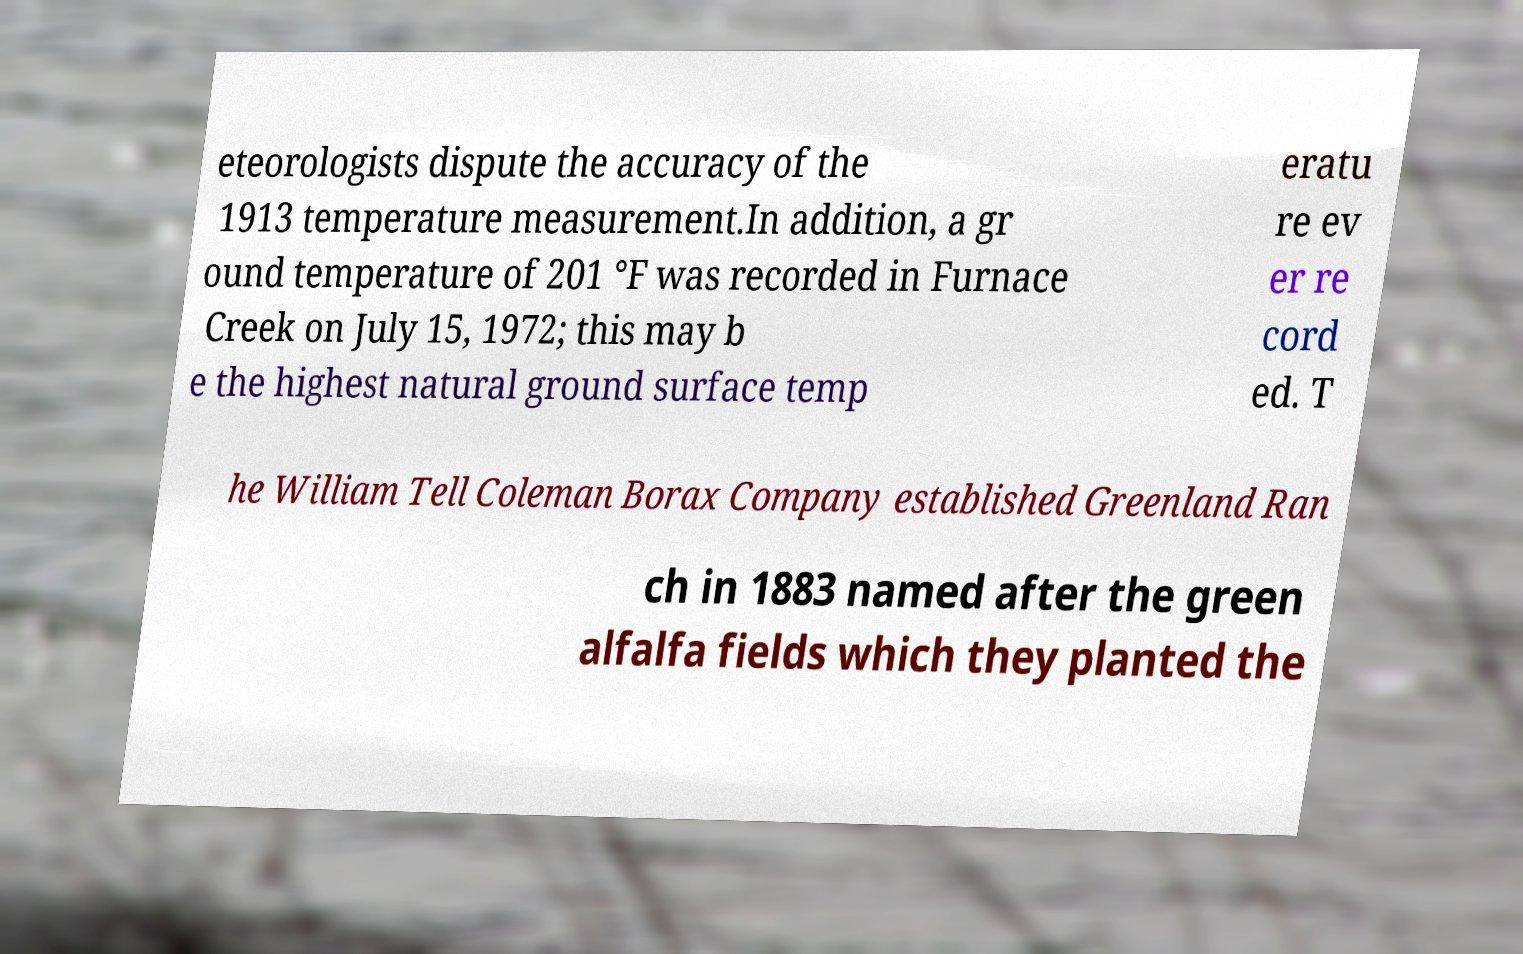Please read and relay the text visible in this image. What does it say? eteorologists dispute the accuracy of the 1913 temperature measurement.In addition, a gr ound temperature of 201 °F was recorded in Furnace Creek on July 15, 1972; this may b e the highest natural ground surface temp eratu re ev er re cord ed. T he William Tell Coleman Borax Company established Greenland Ran ch in 1883 named after the green alfalfa fields which they planted the 